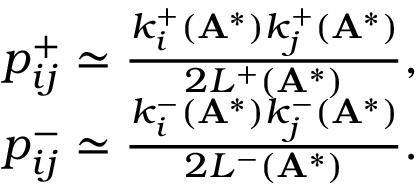<formula> <loc_0><loc_0><loc_500><loc_500>\begin{array} { r } { p _ { i j } ^ { + } \simeq \frac { k _ { i } ^ { + } ( A ^ { * } ) k _ { j } ^ { + } ( A ^ { * } ) } { 2 L ^ { + } ( A ^ { * } ) } , } \\ { p _ { i j } ^ { - } \simeq \frac { k _ { i } ^ { - } ( A ^ { * } ) k _ { j } ^ { - } ( A ^ { * } ) } { 2 L ^ { - } ( A ^ { * } ) } . } \end{array}</formula> 